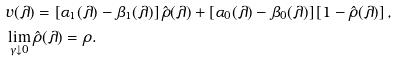<formula> <loc_0><loc_0><loc_500><loc_500>& v ( \lambda ) = \left [ \alpha _ { 1 } ( \lambda ) - \beta _ { 1 } ( \lambda ) \right ] \hat { \rho } ( \lambda ) + \left [ \alpha _ { 0 } ( \lambda ) - \beta _ { 0 } ( \lambda ) \right ] \left [ 1 - \hat { \rho } ( \lambda ) \right ] , \\ & \lim _ { \gamma \downarrow 0 } \hat { \rho } ( \lambda ) = \rho .</formula> 